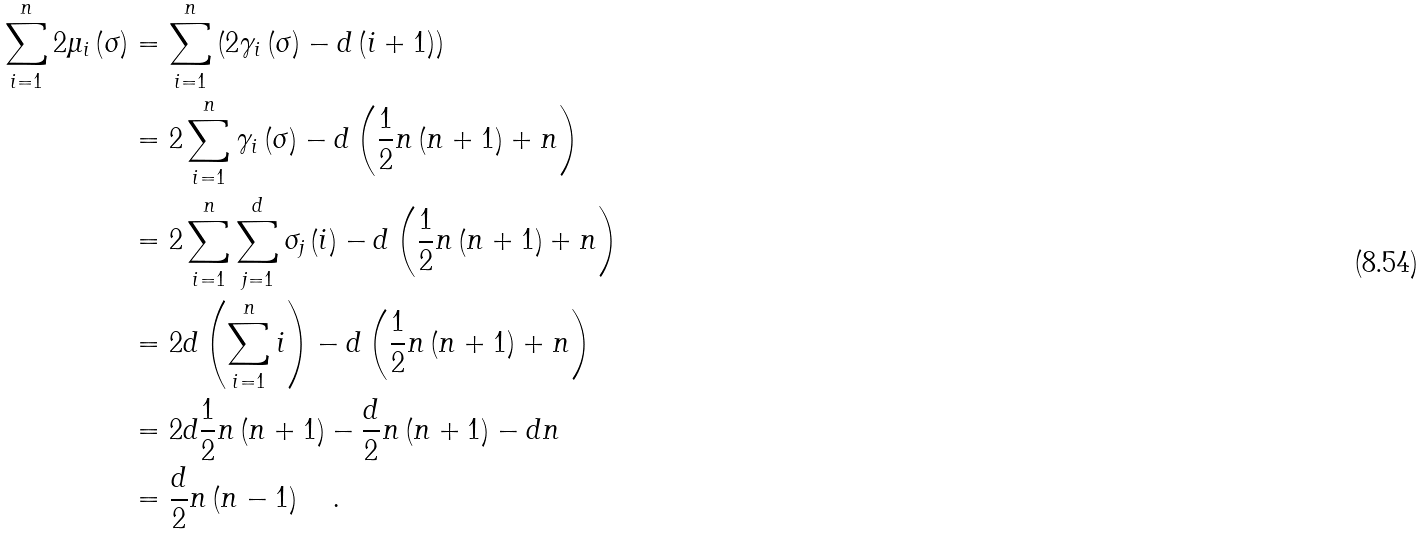Convert formula to latex. <formula><loc_0><loc_0><loc_500><loc_500>\sum _ { i = 1 } ^ { n } 2 \mu _ { i } \left ( \sigma \right ) & = \sum _ { i = 1 } ^ { n } \left ( 2 \gamma _ { i } \left ( \sigma \right ) - d \left ( i + 1 \right ) \right ) \\ & = 2 \sum _ { i = 1 } ^ { n } \gamma _ { i } \left ( \sigma \right ) - d \left ( \frac { 1 } { 2 } n \left ( n + 1 \right ) + n \right ) \\ & = 2 \sum _ { i = 1 } ^ { n } \sum _ { j = 1 } ^ { d } \sigma _ { j } \left ( i \right ) - d \left ( \frac { 1 } { 2 } n \left ( n + 1 \right ) + n \right ) \\ & = 2 d \left ( \sum _ { i = 1 } ^ { n } i \right ) - d \left ( \frac { 1 } { 2 } n \left ( n + 1 \right ) + n \right ) \\ & = 2 d \frac { 1 } { 2 } n \left ( n + 1 \right ) - \frac { d } { 2 } n \left ( n + 1 \right ) - d n \\ & = \frac { d } { 2 } n \left ( n - 1 \right ) \quad .</formula> 